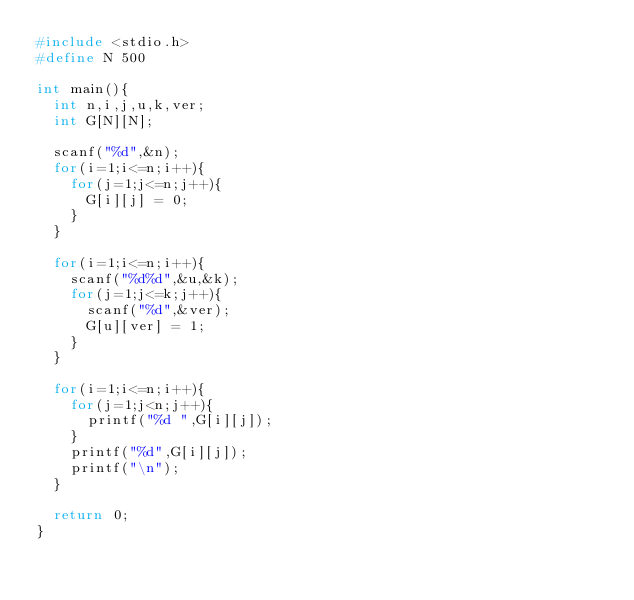<code> <loc_0><loc_0><loc_500><loc_500><_C_>#include <stdio.h>
#define N 500

int main(){
  int n,i,j,u,k,ver;
  int G[N][N];
  
  scanf("%d",&n);
  for(i=1;i<=n;i++){
    for(j=1;j<=n;j++){
      G[i][j] = 0;
    }
  }

  for(i=1;i<=n;i++){
    scanf("%d%d",&u,&k);
    for(j=1;j<=k;j++){
      scanf("%d",&ver);
      G[u][ver] = 1;
    }
  }

  for(i=1;i<=n;i++){
    for(j=1;j<n;j++){
      printf("%d ",G[i][j]);
    }
    printf("%d",G[i][j]);
    printf("\n");
  }
  
  return 0;
}

</code> 